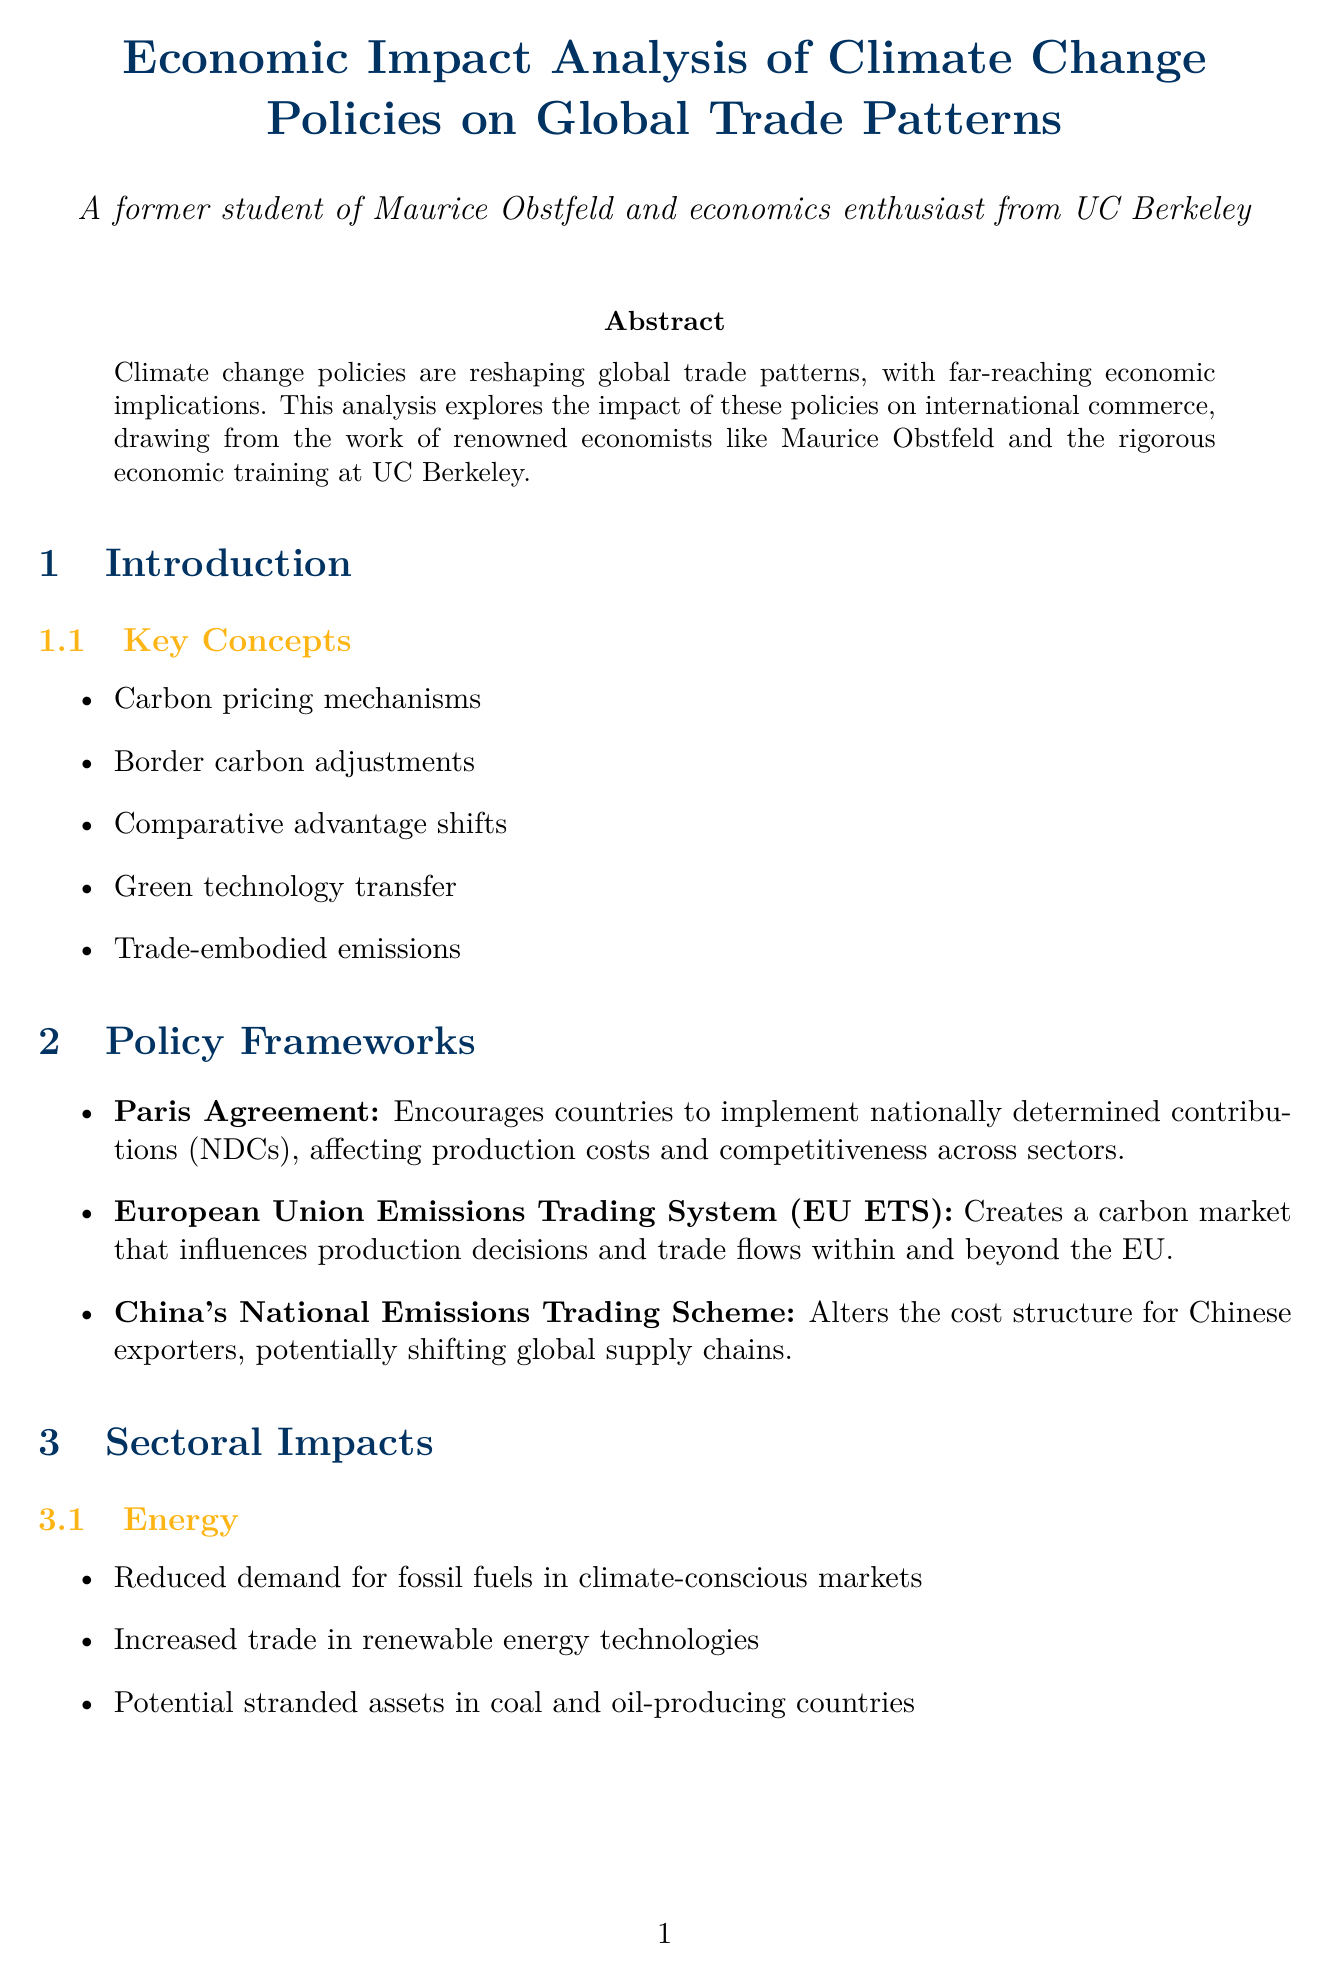What is the title of the report? The title is stated at the beginning of the document.
Answer: Economic Impact Analysis of Climate Change Policies on Global Trade Patterns Which policy encourages countries to implement nationally determined contributions? This information is found under the policy frameworks section.
Answer: Paris Agreement What sector is affected by potential stranded assets in coal and oil-producing countries? This is located in the sectoral impacts section related to energy.
Answer: Energy What economic model is used to simulate economy-wide effects of climate policies on trade? This is mentioned in the economic models section.
Answer: Computable General Equilibrium (CGE) models Which country has proposed a border carbon adjustment mechanism? This is noted in the case studies section under the United States.
Answer: United States What is one future trend mentioned regarding global trade? This is found in the future trends section of the report.
Answer: Emergence of climate clubs and preferential trade agreements based on environmental standards Who contributed to the understanding of long-term trade impacts by integrating climate change into economic models? This information is provided in the expert insights section.
Answer: William Nordhaus What course at UC Berkeley focuses on environmental and resource economics? The courses related to the UC Berkeley connection section.
Answer: ECON 241: Environmental and Resource Economics 